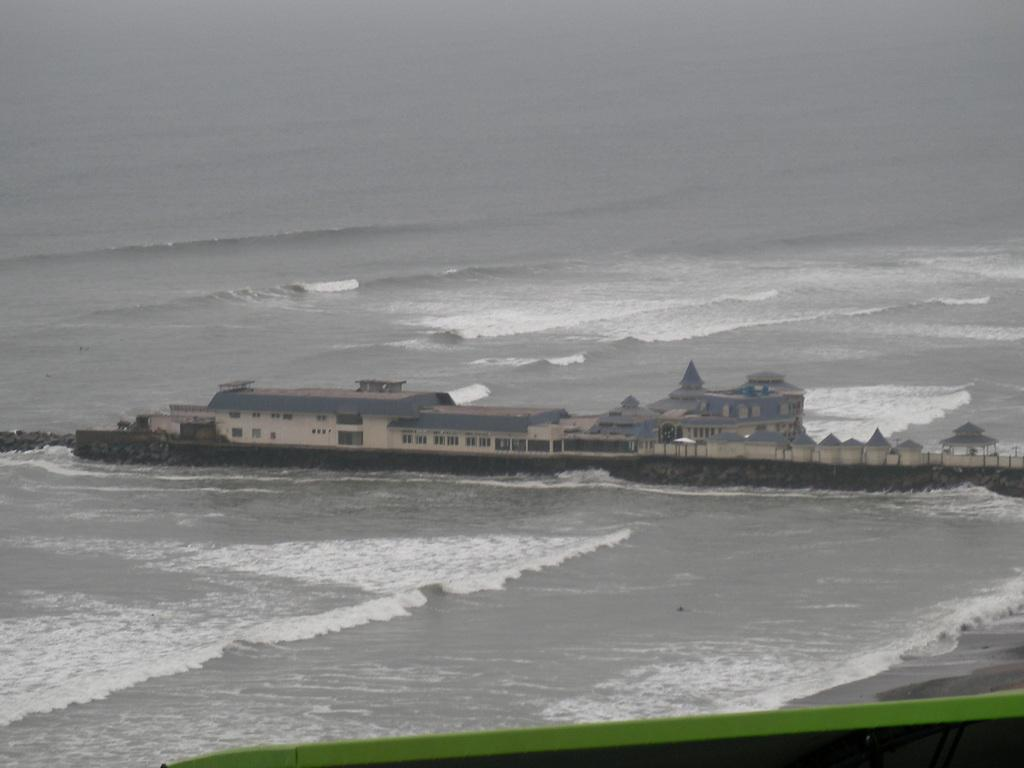What is the main structure visible in the image? There is a building in the image. What surrounds the building on both sides? There is water on either side of the building. Can you describe the object in the right bottom corner of the image? There is a green color object in the right bottom corner of the image. What time does the clock show in the image? There is no clock present in the image. How many passengers are visible in the image? There are no passengers visible in the image. 